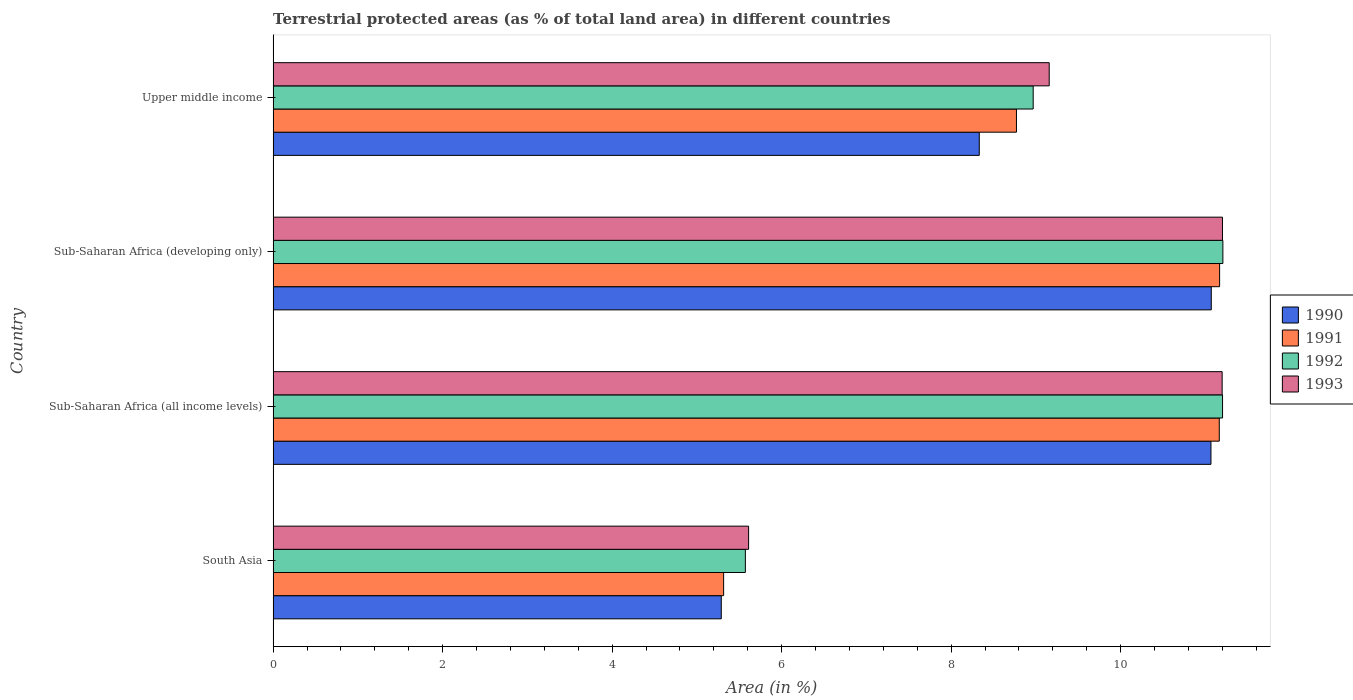How many groups of bars are there?
Provide a short and direct response. 4. Are the number of bars on each tick of the Y-axis equal?
Give a very brief answer. Yes. How many bars are there on the 1st tick from the bottom?
Keep it short and to the point. 4. What is the label of the 3rd group of bars from the top?
Provide a short and direct response. Sub-Saharan Africa (all income levels). What is the percentage of terrestrial protected land in 1993 in Sub-Saharan Africa (developing only)?
Give a very brief answer. 11.2. Across all countries, what is the maximum percentage of terrestrial protected land in 1991?
Provide a succinct answer. 11.17. Across all countries, what is the minimum percentage of terrestrial protected land in 1993?
Provide a short and direct response. 5.61. In which country was the percentage of terrestrial protected land in 1993 maximum?
Make the answer very short. Sub-Saharan Africa (developing only). In which country was the percentage of terrestrial protected land in 1990 minimum?
Provide a succinct answer. South Asia. What is the total percentage of terrestrial protected land in 1993 in the graph?
Your answer should be compact. 37.17. What is the difference between the percentage of terrestrial protected land in 1991 in South Asia and that in Sub-Saharan Africa (developing only)?
Make the answer very short. -5.85. What is the difference between the percentage of terrestrial protected land in 1992 in Sub-Saharan Africa (all income levels) and the percentage of terrestrial protected land in 1990 in Upper middle income?
Keep it short and to the point. 2.87. What is the average percentage of terrestrial protected land in 1991 per country?
Provide a succinct answer. 9.1. What is the difference between the percentage of terrestrial protected land in 1991 and percentage of terrestrial protected land in 1990 in Upper middle income?
Give a very brief answer. 0.44. What is the ratio of the percentage of terrestrial protected land in 1992 in Sub-Saharan Africa (all income levels) to that in Upper middle income?
Offer a terse response. 1.25. Is the percentage of terrestrial protected land in 1990 in South Asia less than that in Upper middle income?
Ensure brevity in your answer.  Yes. Is the difference between the percentage of terrestrial protected land in 1991 in South Asia and Upper middle income greater than the difference between the percentage of terrestrial protected land in 1990 in South Asia and Upper middle income?
Offer a terse response. No. What is the difference between the highest and the second highest percentage of terrestrial protected land in 1991?
Make the answer very short. 0. What is the difference between the highest and the lowest percentage of terrestrial protected land in 1991?
Your answer should be very brief. 5.85. In how many countries, is the percentage of terrestrial protected land in 1992 greater than the average percentage of terrestrial protected land in 1992 taken over all countries?
Your answer should be very brief. 2. Is the sum of the percentage of terrestrial protected land in 1992 in South Asia and Upper middle income greater than the maximum percentage of terrestrial protected land in 1993 across all countries?
Your response must be concise. Yes. What does the 1st bar from the top in Sub-Saharan Africa (all income levels) represents?
Ensure brevity in your answer.  1993. How many bars are there?
Your response must be concise. 16. Are all the bars in the graph horizontal?
Ensure brevity in your answer.  Yes. How many countries are there in the graph?
Offer a terse response. 4. Does the graph contain any zero values?
Ensure brevity in your answer.  No. Does the graph contain grids?
Offer a terse response. No. What is the title of the graph?
Your response must be concise. Terrestrial protected areas (as % of total land area) in different countries. What is the label or title of the X-axis?
Give a very brief answer. Area (in %). What is the label or title of the Y-axis?
Give a very brief answer. Country. What is the Area (in %) in 1990 in South Asia?
Offer a terse response. 5.29. What is the Area (in %) of 1991 in South Asia?
Ensure brevity in your answer.  5.32. What is the Area (in %) in 1992 in South Asia?
Provide a succinct answer. 5.57. What is the Area (in %) in 1993 in South Asia?
Offer a terse response. 5.61. What is the Area (in %) in 1990 in Sub-Saharan Africa (all income levels)?
Your response must be concise. 11.07. What is the Area (in %) of 1991 in Sub-Saharan Africa (all income levels)?
Your answer should be very brief. 11.16. What is the Area (in %) of 1992 in Sub-Saharan Africa (all income levels)?
Provide a succinct answer. 11.2. What is the Area (in %) in 1993 in Sub-Saharan Africa (all income levels)?
Your answer should be very brief. 11.2. What is the Area (in %) in 1990 in Sub-Saharan Africa (developing only)?
Offer a terse response. 11.07. What is the Area (in %) in 1991 in Sub-Saharan Africa (developing only)?
Your answer should be very brief. 11.17. What is the Area (in %) in 1992 in Sub-Saharan Africa (developing only)?
Ensure brevity in your answer.  11.21. What is the Area (in %) in 1993 in Sub-Saharan Africa (developing only)?
Provide a succinct answer. 11.2. What is the Area (in %) of 1990 in Upper middle income?
Offer a terse response. 8.33. What is the Area (in %) of 1991 in Upper middle income?
Ensure brevity in your answer.  8.77. What is the Area (in %) of 1992 in Upper middle income?
Provide a succinct answer. 8.97. What is the Area (in %) in 1993 in Upper middle income?
Ensure brevity in your answer.  9.16. Across all countries, what is the maximum Area (in %) in 1990?
Ensure brevity in your answer.  11.07. Across all countries, what is the maximum Area (in %) of 1991?
Your answer should be very brief. 11.17. Across all countries, what is the maximum Area (in %) in 1992?
Your answer should be very brief. 11.21. Across all countries, what is the maximum Area (in %) in 1993?
Keep it short and to the point. 11.2. Across all countries, what is the minimum Area (in %) of 1990?
Ensure brevity in your answer.  5.29. Across all countries, what is the minimum Area (in %) in 1991?
Your response must be concise. 5.32. Across all countries, what is the minimum Area (in %) of 1992?
Provide a short and direct response. 5.57. Across all countries, what is the minimum Area (in %) of 1993?
Make the answer very short. 5.61. What is the total Area (in %) of 1990 in the graph?
Your response must be concise. 35.76. What is the total Area (in %) of 1991 in the graph?
Give a very brief answer. 36.42. What is the total Area (in %) in 1992 in the graph?
Give a very brief answer. 36.95. What is the total Area (in %) of 1993 in the graph?
Your answer should be very brief. 37.17. What is the difference between the Area (in %) in 1990 in South Asia and that in Sub-Saharan Africa (all income levels)?
Make the answer very short. -5.78. What is the difference between the Area (in %) of 1991 in South Asia and that in Sub-Saharan Africa (all income levels)?
Provide a succinct answer. -5.85. What is the difference between the Area (in %) in 1992 in South Asia and that in Sub-Saharan Africa (all income levels)?
Keep it short and to the point. -5.63. What is the difference between the Area (in %) of 1993 in South Asia and that in Sub-Saharan Africa (all income levels)?
Provide a short and direct response. -5.59. What is the difference between the Area (in %) in 1990 in South Asia and that in Sub-Saharan Africa (developing only)?
Give a very brief answer. -5.78. What is the difference between the Area (in %) in 1991 in South Asia and that in Sub-Saharan Africa (developing only)?
Provide a succinct answer. -5.85. What is the difference between the Area (in %) in 1992 in South Asia and that in Sub-Saharan Africa (developing only)?
Offer a very short reply. -5.63. What is the difference between the Area (in %) in 1993 in South Asia and that in Sub-Saharan Africa (developing only)?
Your response must be concise. -5.59. What is the difference between the Area (in %) in 1990 in South Asia and that in Upper middle income?
Make the answer very short. -3.04. What is the difference between the Area (in %) in 1991 in South Asia and that in Upper middle income?
Offer a terse response. -3.46. What is the difference between the Area (in %) of 1992 in South Asia and that in Upper middle income?
Your response must be concise. -3.4. What is the difference between the Area (in %) of 1993 in South Asia and that in Upper middle income?
Provide a succinct answer. -3.55. What is the difference between the Area (in %) in 1990 in Sub-Saharan Africa (all income levels) and that in Sub-Saharan Africa (developing only)?
Keep it short and to the point. -0. What is the difference between the Area (in %) of 1991 in Sub-Saharan Africa (all income levels) and that in Sub-Saharan Africa (developing only)?
Provide a succinct answer. -0. What is the difference between the Area (in %) in 1992 in Sub-Saharan Africa (all income levels) and that in Sub-Saharan Africa (developing only)?
Offer a terse response. -0. What is the difference between the Area (in %) of 1993 in Sub-Saharan Africa (all income levels) and that in Sub-Saharan Africa (developing only)?
Your response must be concise. -0. What is the difference between the Area (in %) in 1990 in Sub-Saharan Africa (all income levels) and that in Upper middle income?
Give a very brief answer. 2.73. What is the difference between the Area (in %) of 1991 in Sub-Saharan Africa (all income levels) and that in Upper middle income?
Your answer should be compact. 2.39. What is the difference between the Area (in %) of 1992 in Sub-Saharan Africa (all income levels) and that in Upper middle income?
Your answer should be compact. 2.23. What is the difference between the Area (in %) in 1993 in Sub-Saharan Africa (all income levels) and that in Upper middle income?
Your answer should be compact. 2.04. What is the difference between the Area (in %) in 1990 in Sub-Saharan Africa (developing only) and that in Upper middle income?
Ensure brevity in your answer.  2.74. What is the difference between the Area (in %) in 1991 in Sub-Saharan Africa (developing only) and that in Upper middle income?
Ensure brevity in your answer.  2.4. What is the difference between the Area (in %) of 1992 in Sub-Saharan Africa (developing only) and that in Upper middle income?
Give a very brief answer. 2.24. What is the difference between the Area (in %) of 1993 in Sub-Saharan Africa (developing only) and that in Upper middle income?
Your answer should be compact. 2.04. What is the difference between the Area (in %) in 1990 in South Asia and the Area (in %) in 1991 in Sub-Saharan Africa (all income levels)?
Give a very brief answer. -5.88. What is the difference between the Area (in %) in 1990 in South Asia and the Area (in %) in 1992 in Sub-Saharan Africa (all income levels)?
Your response must be concise. -5.91. What is the difference between the Area (in %) of 1990 in South Asia and the Area (in %) of 1993 in Sub-Saharan Africa (all income levels)?
Give a very brief answer. -5.91. What is the difference between the Area (in %) of 1991 in South Asia and the Area (in %) of 1992 in Sub-Saharan Africa (all income levels)?
Offer a very short reply. -5.89. What is the difference between the Area (in %) of 1991 in South Asia and the Area (in %) of 1993 in Sub-Saharan Africa (all income levels)?
Ensure brevity in your answer.  -5.88. What is the difference between the Area (in %) in 1992 in South Asia and the Area (in %) in 1993 in Sub-Saharan Africa (all income levels)?
Ensure brevity in your answer.  -5.63. What is the difference between the Area (in %) in 1990 in South Asia and the Area (in %) in 1991 in Sub-Saharan Africa (developing only)?
Your answer should be compact. -5.88. What is the difference between the Area (in %) in 1990 in South Asia and the Area (in %) in 1992 in Sub-Saharan Africa (developing only)?
Keep it short and to the point. -5.92. What is the difference between the Area (in %) of 1990 in South Asia and the Area (in %) of 1993 in Sub-Saharan Africa (developing only)?
Give a very brief answer. -5.91. What is the difference between the Area (in %) of 1991 in South Asia and the Area (in %) of 1992 in Sub-Saharan Africa (developing only)?
Make the answer very short. -5.89. What is the difference between the Area (in %) of 1991 in South Asia and the Area (in %) of 1993 in Sub-Saharan Africa (developing only)?
Provide a short and direct response. -5.89. What is the difference between the Area (in %) in 1992 in South Asia and the Area (in %) in 1993 in Sub-Saharan Africa (developing only)?
Provide a succinct answer. -5.63. What is the difference between the Area (in %) of 1990 in South Asia and the Area (in %) of 1991 in Upper middle income?
Provide a succinct answer. -3.48. What is the difference between the Area (in %) of 1990 in South Asia and the Area (in %) of 1992 in Upper middle income?
Keep it short and to the point. -3.68. What is the difference between the Area (in %) in 1990 in South Asia and the Area (in %) in 1993 in Upper middle income?
Offer a very short reply. -3.87. What is the difference between the Area (in %) of 1991 in South Asia and the Area (in %) of 1992 in Upper middle income?
Provide a short and direct response. -3.65. What is the difference between the Area (in %) of 1991 in South Asia and the Area (in %) of 1993 in Upper middle income?
Provide a short and direct response. -3.84. What is the difference between the Area (in %) of 1992 in South Asia and the Area (in %) of 1993 in Upper middle income?
Your answer should be compact. -3.59. What is the difference between the Area (in %) in 1990 in Sub-Saharan Africa (all income levels) and the Area (in %) in 1991 in Sub-Saharan Africa (developing only)?
Offer a very short reply. -0.1. What is the difference between the Area (in %) of 1990 in Sub-Saharan Africa (all income levels) and the Area (in %) of 1992 in Sub-Saharan Africa (developing only)?
Give a very brief answer. -0.14. What is the difference between the Area (in %) of 1990 in Sub-Saharan Africa (all income levels) and the Area (in %) of 1993 in Sub-Saharan Africa (developing only)?
Keep it short and to the point. -0.14. What is the difference between the Area (in %) in 1991 in Sub-Saharan Africa (all income levels) and the Area (in %) in 1992 in Sub-Saharan Africa (developing only)?
Ensure brevity in your answer.  -0.04. What is the difference between the Area (in %) in 1991 in Sub-Saharan Africa (all income levels) and the Area (in %) in 1993 in Sub-Saharan Africa (developing only)?
Provide a succinct answer. -0.04. What is the difference between the Area (in %) of 1992 in Sub-Saharan Africa (all income levels) and the Area (in %) of 1993 in Sub-Saharan Africa (developing only)?
Make the answer very short. 0. What is the difference between the Area (in %) in 1990 in Sub-Saharan Africa (all income levels) and the Area (in %) in 1991 in Upper middle income?
Your answer should be very brief. 2.29. What is the difference between the Area (in %) of 1990 in Sub-Saharan Africa (all income levels) and the Area (in %) of 1992 in Upper middle income?
Your response must be concise. 2.1. What is the difference between the Area (in %) in 1990 in Sub-Saharan Africa (all income levels) and the Area (in %) in 1993 in Upper middle income?
Make the answer very short. 1.91. What is the difference between the Area (in %) of 1991 in Sub-Saharan Africa (all income levels) and the Area (in %) of 1992 in Upper middle income?
Give a very brief answer. 2.2. What is the difference between the Area (in %) of 1991 in Sub-Saharan Africa (all income levels) and the Area (in %) of 1993 in Upper middle income?
Keep it short and to the point. 2.01. What is the difference between the Area (in %) in 1992 in Sub-Saharan Africa (all income levels) and the Area (in %) in 1993 in Upper middle income?
Make the answer very short. 2.05. What is the difference between the Area (in %) of 1990 in Sub-Saharan Africa (developing only) and the Area (in %) of 1991 in Upper middle income?
Make the answer very short. 2.3. What is the difference between the Area (in %) of 1990 in Sub-Saharan Africa (developing only) and the Area (in %) of 1992 in Upper middle income?
Give a very brief answer. 2.1. What is the difference between the Area (in %) of 1990 in Sub-Saharan Africa (developing only) and the Area (in %) of 1993 in Upper middle income?
Your answer should be very brief. 1.91. What is the difference between the Area (in %) of 1991 in Sub-Saharan Africa (developing only) and the Area (in %) of 1992 in Upper middle income?
Give a very brief answer. 2.2. What is the difference between the Area (in %) of 1991 in Sub-Saharan Africa (developing only) and the Area (in %) of 1993 in Upper middle income?
Offer a very short reply. 2.01. What is the difference between the Area (in %) in 1992 in Sub-Saharan Africa (developing only) and the Area (in %) in 1993 in Upper middle income?
Ensure brevity in your answer.  2.05. What is the average Area (in %) of 1990 per country?
Offer a terse response. 8.94. What is the average Area (in %) of 1991 per country?
Ensure brevity in your answer.  9.1. What is the average Area (in %) in 1992 per country?
Ensure brevity in your answer.  9.24. What is the average Area (in %) in 1993 per country?
Your answer should be compact. 9.29. What is the difference between the Area (in %) in 1990 and Area (in %) in 1991 in South Asia?
Keep it short and to the point. -0.03. What is the difference between the Area (in %) of 1990 and Area (in %) of 1992 in South Asia?
Your response must be concise. -0.28. What is the difference between the Area (in %) of 1990 and Area (in %) of 1993 in South Asia?
Make the answer very short. -0.32. What is the difference between the Area (in %) in 1991 and Area (in %) in 1992 in South Asia?
Provide a short and direct response. -0.26. What is the difference between the Area (in %) of 1991 and Area (in %) of 1993 in South Asia?
Your answer should be very brief. -0.29. What is the difference between the Area (in %) of 1992 and Area (in %) of 1993 in South Asia?
Your response must be concise. -0.04. What is the difference between the Area (in %) of 1990 and Area (in %) of 1991 in Sub-Saharan Africa (all income levels)?
Give a very brief answer. -0.1. What is the difference between the Area (in %) in 1990 and Area (in %) in 1992 in Sub-Saharan Africa (all income levels)?
Provide a succinct answer. -0.14. What is the difference between the Area (in %) of 1990 and Area (in %) of 1993 in Sub-Saharan Africa (all income levels)?
Your answer should be very brief. -0.13. What is the difference between the Area (in %) in 1991 and Area (in %) in 1992 in Sub-Saharan Africa (all income levels)?
Provide a short and direct response. -0.04. What is the difference between the Area (in %) in 1991 and Area (in %) in 1993 in Sub-Saharan Africa (all income levels)?
Give a very brief answer. -0.03. What is the difference between the Area (in %) in 1992 and Area (in %) in 1993 in Sub-Saharan Africa (all income levels)?
Provide a succinct answer. 0. What is the difference between the Area (in %) in 1990 and Area (in %) in 1991 in Sub-Saharan Africa (developing only)?
Offer a very short reply. -0.1. What is the difference between the Area (in %) of 1990 and Area (in %) of 1992 in Sub-Saharan Africa (developing only)?
Provide a succinct answer. -0.14. What is the difference between the Area (in %) in 1990 and Area (in %) in 1993 in Sub-Saharan Africa (developing only)?
Offer a very short reply. -0.13. What is the difference between the Area (in %) of 1991 and Area (in %) of 1992 in Sub-Saharan Africa (developing only)?
Keep it short and to the point. -0.04. What is the difference between the Area (in %) of 1991 and Area (in %) of 1993 in Sub-Saharan Africa (developing only)?
Your answer should be compact. -0.03. What is the difference between the Area (in %) in 1992 and Area (in %) in 1993 in Sub-Saharan Africa (developing only)?
Make the answer very short. 0. What is the difference between the Area (in %) in 1990 and Area (in %) in 1991 in Upper middle income?
Your answer should be compact. -0.44. What is the difference between the Area (in %) in 1990 and Area (in %) in 1992 in Upper middle income?
Provide a succinct answer. -0.64. What is the difference between the Area (in %) in 1990 and Area (in %) in 1993 in Upper middle income?
Make the answer very short. -0.83. What is the difference between the Area (in %) in 1991 and Area (in %) in 1992 in Upper middle income?
Your answer should be very brief. -0.2. What is the difference between the Area (in %) of 1991 and Area (in %) of 1993 in Upper middle income?
Your answer should be very brief. -0.39. What is the difference between the Area (in %) in 1992 and Area (in %) in 1993 in Upper middle income?
Provide a short and direct response. -0.19. What is the ratio of the Area (in %) in 1990 in South Asia to that in Sub-Saharan Africa (all income levels)?
Give a very brief answer. 0.48. What is the ratio of the Area (in %) in 1991 in South Asia to that in Sub-Saharan Africa (all income levels)?
Ensure brevity in your answer.  0.48. What is the ratio of the Area (in %) of 1992 in South Asia to that in Sub-Saharan Africa (all income levels)?
Your response must be concise. 0.5. What is the ratio of the Area (in %) of 1993 in South Asia to that in Sub-Saharan Africa (all income levels)?
Offer a terse response. 0.5. What is the ratio of the Area (in %) of 1990 in South Asia to that in Sub-Saharan Africa (developing only)?
Offer a terse response. 0.48. What is the ratio of the Area (in %) of 1991 in South Asia to that in Sub-Saharan Africa (developing only)?
Make the answer very short. 0.48. What is the ratio of the Area (in %) of 1992 in South Asia to that in Sub-Saharan Africa (developing only)?
Offer a very short reply. 0.5. What is the ratio of the Area (in %) of 1993 in South Asia to that in Sub-Saharan Africa (developing only)?
Your response must be concise. 0.5. What is the ratio of the Area (in %) in 1990 in South Asia to that in Upper middle income?
Offer a terse response. 0.63. What is the ratio of the Area (in %) in 1991 in South Asia to that in Upper middle income?
Provide a succinct answer. 0.61. What is the ratio of the Area (in %) in 1992 in South Asia to that in Upper middle income?
Your answer should be very brief. 0.62. What is the ratio of the Area (in %) in 1993 in South Asia to that in Upper middle income?
Your answer should be very brief. 0.61. What is the ratio of the Area (in %) in 1990 in Sub-Saharan Africa (all income levels) to that in Sub-Saharan Africa (developing only)?
Offer a terse response. 1. What is the ratio of the Area (in %) of 1992 in Sub-Saharan Africa (all income levels) to that in Sub-Saharan Africa (developing only)?
Offer a very short reply. 1. What is the ratio of the Area (in %) of 1990 in Sub-Saharan Africa (all income levels) to that in Upper middle income?
Your response must be concise. 1.33. What is the ratio of the Area (in %) in 1991 in Sub-Saharan Africa (all income levels) to that in Upper middle income?
Your answer should be compact. 1.27. What is the ratio of the Area (in %) in 1992 in Sub-Saharan Africa (all income levels) to that in Upper middle income?
Your response must be concise. 1.25. What is the ratio of the Area (in %) of 1993 in Sub-Saharan Africa (all income levels) to that in Upper middle income?
Provide a succinct answer. 1.22. What is the ratio of the Area (in %) of 1990 in Sub-Saharan Africa (developing only) to that in Upper middle income?
Your response must be concise. 1.33. What is the ratio of the Area (in %) in 1991 in Sub-Saharan Africa (developing only) to that in Upper middle income?
Your answer should be compact. 1.27. What is the ratio of the Area (in %) in 1992 in Sub-Saharan Africa (developing only) to that in Upper middle income?
Provide a succinct answer. 1.25. What is the ratio of the Area (in %) in 1993 in Sub-Saharan Africa (developing only) to that in Upper middle income?
Your answer should be compact. 1.22. What is the difference between the highest and the second highest Area (in %) in 1990?
Keep it short and to the point. 0. What is the difference between the highest and the second highest Area (in %) of 1991?
Offer a terse response. 0. What is the difference between the highest and the second highest Area (in %) in 1992?
Offer a very short reply. 0. What is the difference between the highest and the second highest Area (in %) in 1993?
Offer a terse response. 0. What is the difference between the highest and the lowest Area (in %) in 1990?
Your answer should be very brief. 5.78. What is the difference between the highest and the lowest Area (in %) in 1991?
Provide a short and direct response. 5.85. What is the difference between the highest and the lowest Area (in %) of 1992?
Offer a very short reply. 5.63. What is the difference between the highest and the lowest Area (in %) in 1993?
Offer a very short reply. 5.59. 